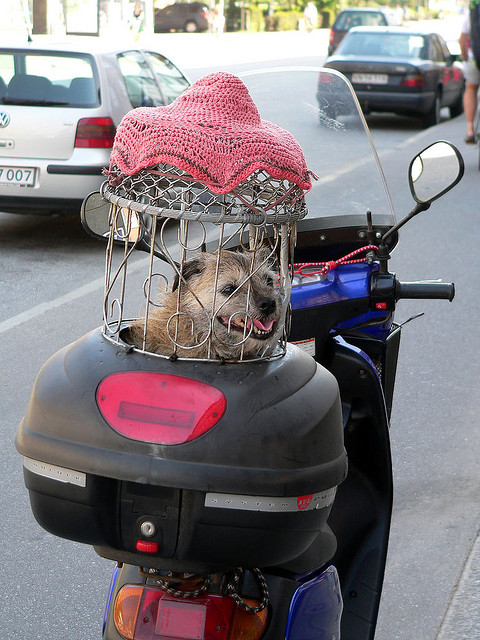Please transcribe the text information in this image. 007 